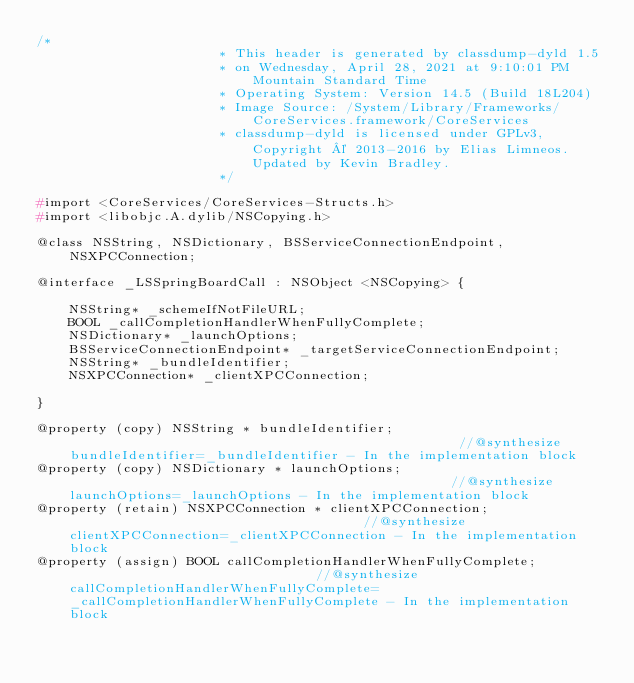Convert code to text. <code><loc_0><loc_0><loc_500><loc_500><_C_>/*
                       * This header is generated by classdump-dyld 1.5
                       * on Wednesday, April 28, 2021 at 9:10:01 PM Mountain Standard Time
                       * Operating System: Version 14.5 (Build 18L204)
                       * Image Source: /System/Library/Frameworks/CoreServices.framework/CoreServices
                       * classdump-dyld is licensed under GPLv3, Copyright © 2013-2016 by Elias Limneos. Updated by Kevin Bradley.
                       */

#import <CoreServices/CoreServices-Structs.h>
#import <libobjc.A.dylib/NSCopying.h>

@class NSString, NSDictionary, BSServiceConnectionEndpoint, NSXPCConnection;

@interface _LSSpringBoardCall : NSObject <NSCopying> {

	NSString* _schemeIfNotFileURL;
	BOOL _callCompletionHandlerWhenFullyComplete;
	NSDictionary* _launchOptions;
	BSServiceConnectionEndpoint* _targetServiceConnectionEndpoint;
	NSString* _bundleIdentifier;
	NSXPCConnection* _clientXPCConnection;

}

@property (copy) NSString * bundleIdentifier;                                                  //@synthesize bundleIdentifier=_bundleIdentifier - In the implementation block
@property (copy) NSDictionary * launchOptions;                                                 //@synthesize launchOptions=_launchOptions - In the implementation block
@property (retain) NSXPCConnection * clientXPCConnection;                                      //@synthesize clientXPCConnection=_clientXPCConnection - In the implementation block
@property (assign) BOOL callCompletionHandlerWhenFullyComplete;                                //@synthesize callCompletionHandlerWhenFullyComplete=_callCompletionHandlerWhenFullyComplete - In the implementation block</code> 